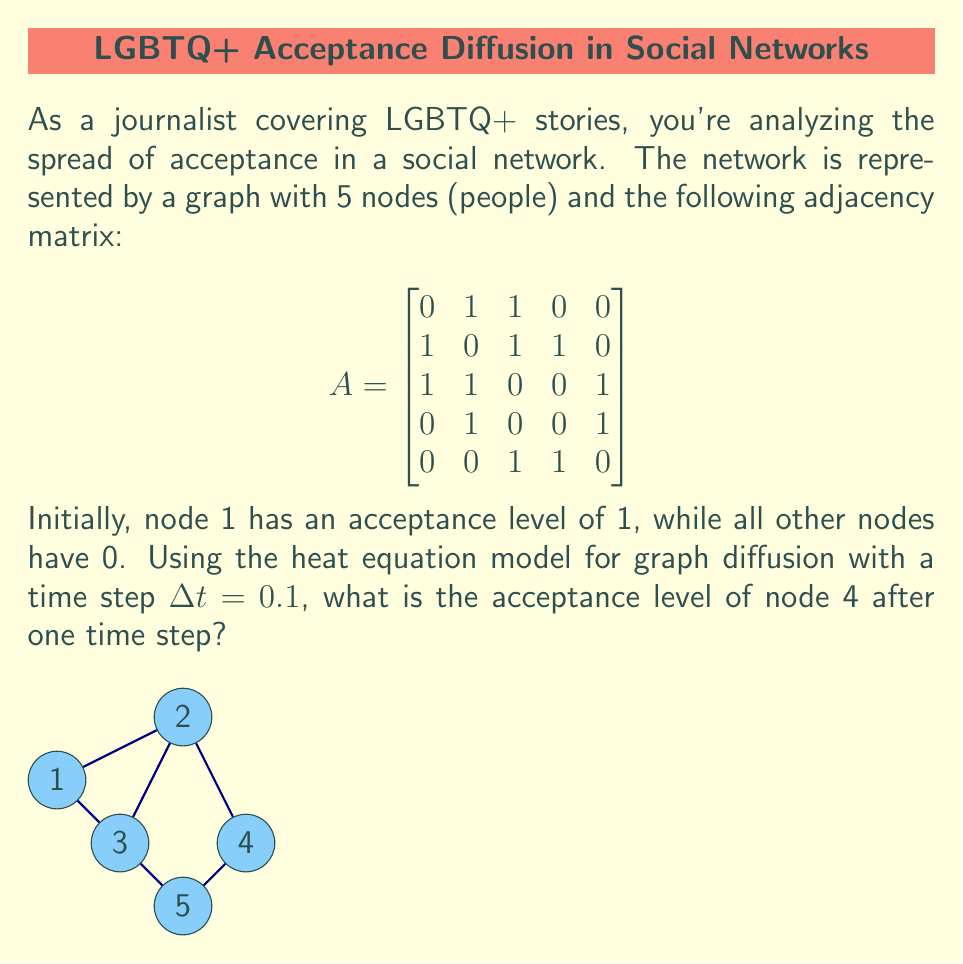What is the answer to this math problem? To solve this problem, we'll use the heat equation model for graph diffusion:

$$\frac{du}{dt} = -Lu$$

where $L$ is the graph Laplacian and $u$ is the vector of acceptance levels.

Step 1: Calculate the graph Laplacian $L = D - A$, where $D$ is the degree matrix.
$$D = \begin{bmatrix}
2 & 0 & 0 & 0 & 0 \\
0 & 3 & 0 & 0 & 0 \\
0 & 0 & 3 & 0 & 0 \\
0 & 0 & 0 & 2 & 0 \\
0 & 0 & 0 & 0 & 2
\end{bmatrix}$$

$$L = D - A = \begin{bmatrix}
2 & -1 & -1 & 0 & 0 \\
-1 & 3 & -1 & -1 & 0 \\
-1 & -1 & 3 & 0 & -1 \\
0 & -1 & 0 & 2 & -1 \\
0 & 0 & -1 & -1 & 2
\end{bmatrix}$$

Step 2: Set up the initial condition vector $u_0$.
$$u_0 = \begin{bmatrix} 1 \\ 0 \\ 0 \\ 0 \\ 0 \end{bmatrix}$$

Step 3: Use the forward Euler method to approximate the solution after one time step.
$$u_1 = u_0 - \Delta t \cdot Lu_0$$

Step 4: Compute $u_1$.
$$u_1 = \begin{bmatrix} 1 \\ 0 \\ 0 \\ 0 \\ 0 \end{bmatrix} - 0.1 \cdot \begin{bmatrix}
2 & -1 & -1 & 0 & 0 \\
-1 & 3 & -1 & -1 & 0 \\
-1 & -1 & 3 & 0 & -1 \\
0 & -1 & 0 & 2 & -1 \\
0 & 0 & -1 & -1 & 2
\end{bmatrix} \begin{bmatrix} 1 \\ 0 \\ 0 \\ 0 \\ 0 \end{bmatrix}$$

$$u_1 = \begin{bmatrix} 1 \\ 0 \\ 0 \\ 0 \\ 0 \end{bmatrix} - 0.1 \cdot \begin{bmatrix} 2 \\ -1 \\ -1 \\ 0 \\ 0 \end{bmatrix} = \begin{bmatrix} 0.8 \\ 0.1 \\ 0.1 \\ 0 \\ 0 \end{bmatrix}$$

Step 5: The acceptance level of node 4 (fourth element of $u_1$) is 0.
Answer: 0 